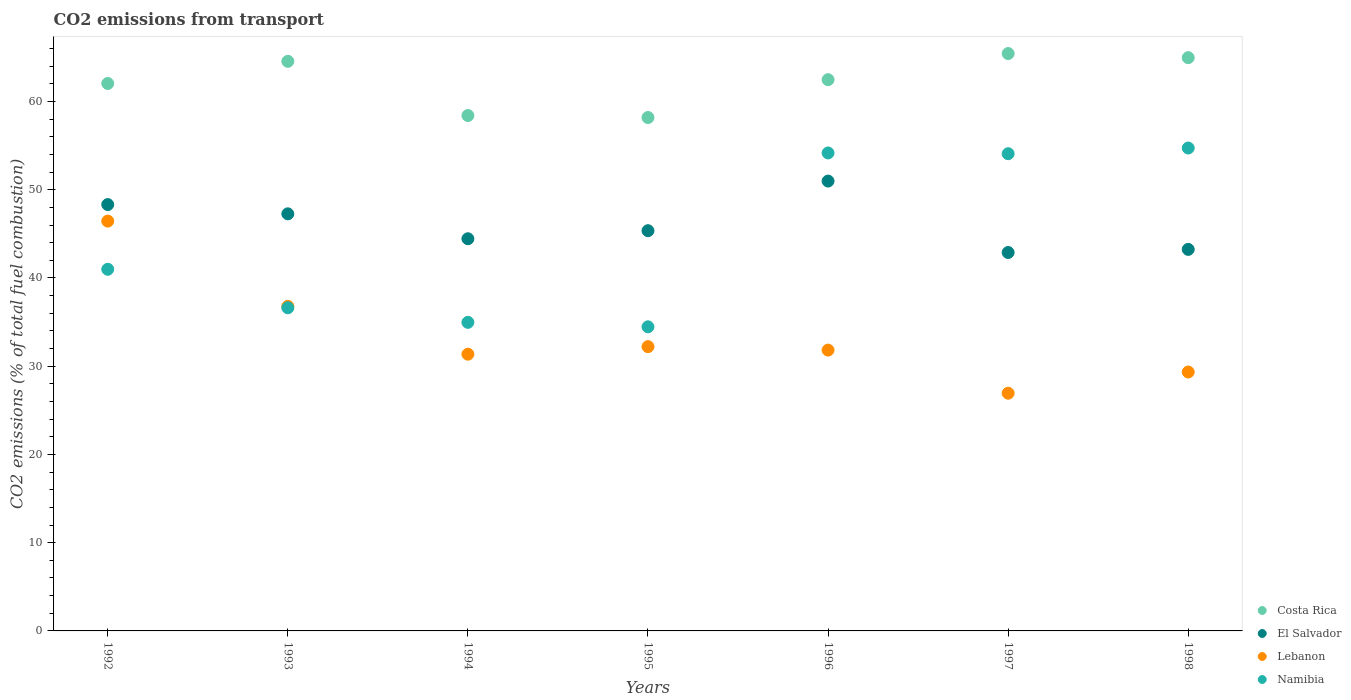Is the number of dotlines equal to the number of legend labels?
Provide a succinct answer. Yes. What is the total CO2 emitted in Costa Rica in 1992?
Provide a succinct answer. 62.04. Across all years, what is the maximum total CO2 emitted in Namibia?
Your answer should be very brief. 54.73. Across all years, what is the minimum total CO2 emitted in Namibia?
Provide a succinct answer. 34.46. In which year was the total CO2 emitted in Lebanon minimum?
Keep it short and to the point. 1997. What is the total total CO2 emitted in El Salvador in the graph?
Your response must be concise. 322.49. What is the difference between the total CO2 emitted in El Salvador in 1996 and that in 1998?
Provide a succinct answer. 7.74. What is the difference between the total CO2 emitted in Costa Rica in 1994 and the total CO2 emitted in Lebanon in 1997?
Offer a very short reply. 31.47. What is the average total CO2 emitted in El Salvador per year?
Your response must be concise. 46.07. In the year 1996, what is the difference between the total CO2 emitted in El Salvador and total CO2 emitted in Costa Rica?
Make the answer very short. -11.49. What is the ratio of the total CO2 emitted in El Salvador in 1994 to that in 1996?
Keep it short and to the point. 0.87. Is the total CO2 emitted in Lebanon in 1994 less than that in 1998?
Provide a short and direct response. No. What is the difference between the highest and the second highest total CO2 emitted in Costa Rica?
Your answer should be very brief. 0.47. What is the difference between the highest and the lowest total CO2 emitted in Namibia?
Give a very brief answer. 20.26. In how many years, is the total CO2 emitted in Namibia greater than the average total CO2 emitted in Namibia taken over all years?
Give a very brief answer. 3. Is the sum of the total CO2 emitted in Lebanon in 1995 and 1998 greater than the maximum total CO2 emitted in Namibia across all years?
Your response must be concise. Yes. Is the total CO2 emitted in Namibia strictly greater than the total CO2 emitted in Costa Rica over the years?
Your response must be concise. No. Is the total CO2 emitted in Namibia strictly less than the total CO2 emitted in Lebanon over the years?
Your answer should be very brief. No. What is the difference between two consecutive major ticks on the Y-axis?
Give a very brief answer. 10. Does the graph contain any zero values?
Your answer should be very brief. No. How many legend labels are there?
Ensure brevity in your answer.  4. What is the title of the graph?
Provide a short and direct response. CO2 emissions from transport. Does "Mauritius" appear as one of the legend labels in the graph?
Your answer should be very brief. No. What is the label or title of the X-axis?
Provide a succinct answer. Years. What is the label or title of the Y-axis?
Ensure brevity in your answer.  CO2 emissions (% of total fuel combustion). What is the CO2 emissions (% of total fuel combustion) in Costa Rica in 1992?
Provide a succinct answer. 62.04. What is the CO2 emissions (% of total fuel combustion) in El Salvador in 1992?
Offer a very short reply. 48.32. What is the CO2 emissions (% of total fuel combustion) in Lebanon in 1992?
Provide a succinct answer. 46.44. What is the CO2 emissions (% of total fuel combustion) of Namibia in 1992?
Give a very brief answer. 40.98. What is the CO2 emissions (% of total fuel combustion) of Costa Rica in 1993?
Keep it short and to the point. 64.55. What is the CO2 emissions (% of total fuel combustion) in El Salvador in 1993?
Your answer should be compact. 47.27. What is the CO2 emissions (% of total fuel combustion) in Lebanon in 1993?
Offer a terse response. 36.79. What is the CO2 emissions (% of total fuel combustion) in Namibia in 1993?
Offer a terse response. 36.62. What is the CO2 emissions (% of total fuel combustion) in Costa Rica in 1994?
Provide a short and direct response. 58.41. What is the CO2 emissions (% of total fuel combustion) of El Salvador in 1994?
Provide a short and direct response. 44.44. What is the CO2 emissions (% of total fuel combustion) in Lebanon in 1994?
Provide a succinct answer. 31.36. What is the CO2 emissions (% of total fuel combustion) of Namibia in 1994?
Ensure brevity in your answer.  34.97. What is the CO2 emissions (% of total fuel combustion) in Costa Rica in 1995?
Ensure brevity in your answer.  58.18. What is the CO2 emissions (% of total fuel combustion) of El Salvador in 1995?
Your answer should be compact. 45.36. What is the CO2 emissions (% of total fuel combustion) of Lebanon in 1995?
Your answer should be compact. 32.22. What is the CO2 emissions (% of total fuel combustion) of Namibia in 1995?
Give a very brief answer. 34.46. What is the CO2 emissions (% of total fuel combustion) of Costa Rica in 1996?
Provide a succinct answer. 62.47. What is the CO2 emissions (% of total fuel combustion) in El Salvador in 1996?
Offer a terse response. 50.98. What is the CO2 emissions (% of total fuel combustion) of Lebanon in 1996?
Ensure brevity in your answer.  31.82. What is the CO2 emissions (% of total fuel combustion) in Namibia in 1996?
Offer a terse response. 54.17. What is the CO2 emissions (% of total fuel combustion) of Costa Rica in 1997?
Provide a short and direct response. 65.43. What is the CO2 emissions (% of total fuel combustion) of El Salvador in 1997?
Offer a terse response. 42.89. What is the CO2 emissions (% of total fuel combustion) of Lebanon in 1997?
Offer a terse response. 26.94. What is the CO2 emissions (% of total fuel combustion) of Namibia in 1997?
Offer a very short reply. 54.08. What is the CO2 emissions (% of total fuel combustion) of Costa Rica in 1998?
Keep it short and to the point. 64.97. What is the CO2 emissions (% of total fuel combustion) of El Salvador in 1998?
Offer a very short reply. 43.24. What is the CO2 emissions (% of total fuel combustion) of Lebanon in 1998?
Your answer should be very brief. 29.34. What is the CO2 emissions (% of total fuel combustion) in Namibia in 1998?
Offer a terse response. 54.73. Across all years, what is the maximum CO2 emissions (% of total fuel combustion) in Costa Rica?
Offer a terse response. 65.43. Across all years, what is the maximum CO2 emissions (% of total fuel combustion) in El Salvador?
Your answer should be compact. 50.98. Across all years, what is the maximum CO2 emissions (% of total fuel combustion) in Lebanon?
Give a very brief answer. 46.44. Across all years, what is the maximum CO2 emissions (% of total fuel combustion) in Namibia?
Offer a terse response. 54.73. Across all years, what is the minimum CO2 emissions (% of total fuel combustion) of Costa Rica?
Provide a succinct answer. 58.18. Across all years, what is the minimum CO2 emissions (% of total fuel combustion) of El Salvador?
Your answer should be very brief. 42.89. Across all years, what is the minimum CO2 emissions (% of total fuel combustion) of Lebanon?
Offer a terse response. 26.94. Across all years, what is the minimum CO2 emissions (% of total fuel combustion) of Namibia?
Offer a terse response. 34.46. What is the total CO2 emissions (% of total fuel combustion) in Costa Rica in the graph?
Provide a succinct answer. 436.05. What is the total CO2 emissions (% of total fuel combustion) of El Salvador in the graph?
Your answer should be very brief. 322.49. What is the total CO2 emissions (% of total fuel combustion) of Lebanon in the graph?
Make the answer very short. 234.92. What is the total CO2 emissions (% of total fuel combustion) in Namibia in the graph?
Your response must be concise. 310.01. What is the difference between the CO2 emissions (% of total fuel combustion) in Costa Rica in 1992 and that in 1993?
Ensure brevity in your answer.  -2.51. What is the difference between the CO2 emissions (% of total fuel combustion) of El Salvador in 1992 and that in 1993?
Your answer should be very brief. 1.05. What is the difference between the CO2 emissions (% of total fuel combustion) in Lebanon in 1992 and that in 1993?
Offer a very short reply. 9.66. What is the difference between the CO2 emissions (% of total fuel combustion) of Namibia in 1992 and that in 1993?
Offer a very short reply. 4.36. What is the difference between the CO2 emissions (% of total fuel combustion) of Costa Rica in 1992 and that in 1994?
Your answer should be very brief. 3.63. What is the difference between the CO2 emissions (% of total fuel combustion) of El Salvador in 1992 and that in 1994?
Your answer should be compact. 3.87. What is the difference between the CO2 emissions (% of total fuel combustion) in Lebanon in 1992 and that in 1994?
Make the answer very short. 15.08. What is the difference between the CO2 emissions (% of total fuel combustion) of Namibia in 1992 and that in 1994?
Keep it short and to the point. 6.01. What is the difference between the CO2 emissions (% of total fuel combustion) in Costa Rica in 1992 and that in 1995?
Your response must be concise. 3.86. What is the difference between the CO2 emissions (% of total fuel combustion) of El Salvador in 1992 and that in 1995?
Provide a short and direct response. 2.96. What is the difference between the CO2 emissions (% of total fuel combustion) of Lebanon in 1992 and that in 1995?
Your answer should be very brief. 14.23. What is the difference between the CO2 emissions (% of total fuel combustion) of Namibia in 1992 and that in 1995?
Provide a short and direct response. 6.52. What is the difference between the CO2 emissions (% of total fuel combustion) in Costa Rica in 1992 and that in 1996?
Provide a succinct answer. -0.43. What is the difference between the CO2 emissions (% of total fuel combustion) in El Salvador in 1992 and that in 1996?
Make the answer very short. -2.66. What is the difference between the CO2 emissions (% of total fuel combustion) in Lebanon in 1992 and that in 1996?
Offer a very short reply. 14.62. What is the difference between the CO2 emissions (% of total fuel combustion) in Namibia in 1992 and that in 1996?
Give a very brief answer. -13.18. What is the difference between the CO2 emissions (% of total fuel combustion) in Costa Rica in 1992 and that in 1997?
Keep it short and to the point. -3.39. What is the difference between the CO2 emissions (% of total fuel combustion) in El Salvador in 1992 and that in 1997?
Your answer should be very brief. 5.43. What is the difference between the CO2 emissions (% of total fuel combustion) in Lebanon in 1992 and that in 1997?
Give a very brief answer. 19.5. What is the difference between the CO2 emissions (% of total fuel combustion) in Namibia in 1992 and that in 1997?
Your response must be concise. -13.1. What is the difference between the CO2 emissions (% of total fuel combustion) of Costa Rica in 1992 and that in 1998?
Offer a terse response. -2.92. What is the difference between the CO2 emissions (% of total fuel combustion) in El Salvador in 1992 and that in 1998?
Provide a short and direct response. 5.08. What is the difference between the CO2 emissions (% of total fuel combustion) in Lebanon in 1992 and that in 1998?
Make the answer very short. 17.1. What is the difference between the CO2 emissions (% of total fuel combustion) of Namibia in 1992 and that in 1998?
Give a very brief answer. -13.74. What is the difference between the CO2 emissions (% of total fuel combustion) of Costa Rica in 1993 and that in 1994?
Your answer should be compact. 6.14. What is the difference between the CO2 emissions (% of total fuel combustion) in El Salvador in 1993 and that in 1994?
Ensure brevity in your answer.  2.82. What is the difference between the CO2 emissions (% of total fuel combustion) in Lebanon in 1993 and that in 1994?
Your response must be concise. 5.42. What is the difference between the CO2 emissions (% of total fuel combustion) of Namibia in 1993 and that in 1994?
Provide a succinct answer. 1.65. What is the difference between the CO2 emissions (% of total fuel combustion) in Costa Rica in 1993 and that in 1995?
Ensure brevity in your answer.  6.37. What is the difference between the CO2 emissions (% of total fuel combustion) in El Salvador in 1993 and that in 1995?
Your answer should be compact. 1.91. What is the difference between the CO2 emissions (% of total fuel combustion) in Lebanon in 1993 and that in 1995?
Ensure brevity in your answer.  4.57. What is the difference between the CO2 emissions (% of total fuel combustion) in Namibia in 1993 and that in 1995?
Offer a terse response. 2.16. What is the difference between the CO2 emissions (% of total fuel combustion) in Costa Rica in 1993 and that in 1996?
Keep it short and to the point. 2.08. What is the difference between the CO2 emissions (% of total fuel combustion) in El Salvador in 1993 and that in 1996?
Offer a terse response. -3.71. What is the difference between the CO2 emissions (% of total fuel combustion) of Lebanon in 1993 and that in 1996?
Offer a terse response. 4.96. What is the difference between the CO2 emissions (% of total fuel combustion) in Namibia in 1993 and that in 1996?
Your response must be concise. -17.55. What is the difference between the CO2 emissions (% of total fuel combustion) of Costa Rica in 1993 and that in 1997?
Provide a succinct answer. -0.88. What is the difference between the CO2 emissions (% of total fuel combustion) of El Salvador in 1993 and that in 1997?
Your answer should be very brief. 4.38. What is the difference between the CO2 emissions (% of total fuel combustion) in Lebanon in 1993 and that in 1997?
Provide a short and direct response. 9.84. What is the difference between the CO2 emissions (% of total fuel combustion) in Namibia in 1993 and that in 1997?
Give a very brief answer. -17.46. What is the difference between the CO2 emissions (% of total fuel combustion) in Costa Rica in 1993 and that in 1998?
Provide a succinct answer. -0.42. What is the difference between the CO2 emissions (% of total fuel combustion) in El Salvador in 1993 and that in 1998?
Your response must be concise. 4.03. What is the difference between the CO2 emissions (% of total fuel combustion) in Lebanon in 1993 and that in 1998?
Your answer should be compact. 7.44. What is the difference between the CO2 emissions (% of total fuel combustion) of Namibia in 1993 and that in 1998?
Your answer should be compact. -18.11. What is the difference between the CO2 emissions (% of total fuel combustion) of Costa Rica in 1994 and that in 1995?
Provide a short and direct response. 0.23. What is the difference between the CO2 emissions (% of total fuel combustion) of El Salvador in 1994 and that in 1995?
Offer a terse response. -0.91. What is the difference between the CO2 emissions (% of total fuel combustion) of Lebanon in 1994 and that in 1995?
Keep it short and to the point. -0.86. What is the difference between the CO2 emissions (% of total fuel combustion) of Namibia in 1994 and that in 1995?
Offer a very short reply. 0.51. What is the difference between the CO2 emissions (% of total fuel combustion) of Costa Rica in 1994 and that in 1996?
Your answer should be compact. -4.06. What is the difference between the CO2 emissions (% of total fuel combustion) in El Salvador in 1994 and that in 1996?
Your answer should be very brief. -6.54. What is the difference between the CO2 emissions (% of total fuel combustion) in Lebanon in 1994 and that in 1996?
Your answer should be compact. -0.46. What is the difference between the CO2 emissions (% of total fuel combustion) in Namibia in 1994 and that in 1996?
Provide a succinct answer. -19.2. What is the difference between the CO2 emissions (% of total fuel combustion) of Costa Rica in 1994 and that in 1997?
Offer a terse response. -7.02. What is the difference between the CO2 emissions (% of total fuel combustion) in El Salvador in 1994 and that in 1997?
Make the answer very short. 1.56. What is the difference between the CO2 emissions (% of total fuel combustion) of Lebanon in 1994 and that in 1997?
Keep it short and to the point. 4.42. What is the difference between the CO2 emissions (% of total fuel combustion) in Namibia in 1994 and that in 1997?
Offer a terse response. -19.11. What is the difference between the CO2 emissions (% of total fuel combustion) of Costa Rica in 1994 and that in 1998?
Ensure brevity in your answer.  -6.56. What is the difference between the CO2 emissions (% of total fuel combustion) of El Salvador in 1994 and that in 1998?
Make the answer very short. 1.21. What is the difference between the CO2 emissions (% of total fuel combustion) in Lebanon in 1994 and that in 1998?
Offer a very short reply. 2.02. What is the difference between the CO2 emissions (% of total fuel combustion) of Namibia in 1994 and that in 1998?
Provide a succinct answer. -19.76. What is the difference between the CO2 emissions (% of total fuel combustion) of Costa Rica in 1995 and that in 1996?
Make the answer very short. -4.29. What is the difference between the CO2 emissions (% of total fuel combustion) of El Salvador in 1995 and that in 1996?
Your answer should be very brief. -5.62. What is the difference between the CO2 emissions (% of total fuel combustion) in Lebanon in 1995 and that in 1996?
Give a very brief answer. 0.39. What is the difference between the CO2 emissions (% of total fuel combustion) in Namibia in 1995 and that in 1996?
Make the answer very short. -19.7. What is the difference between the CO2 emissions (% of total fuel combustion) in Costa Rica in 1995 and that in 1997?
Your response must be concise. -7.25. What is the difference between the CO2 emissions (% of total fuel combustion) in El Salvador in 1995 and that in 1997?
Ensure brevity in your answer.  2.47. What is the difference between the CO2 emissions (% of total fuel combustion) of Lebanon in 1995 and that in 1997?
Your answer should be very brief. 5.28. What is the difference between the CO2 emissions (% of total fuel combustion) of Namibia in 1995 and that in 1997?
Provide a short and direct response. -19.62. What is the difference between the CO2 emissions (% of total fuel combustion) in Costa Rica in 1995 and that in 1998?
Your answer should be very brief. -6.78. What is the difference between the CO2 emissions (% of total fuel combustion) in El Salvador in 1995 and that in 1998?
Ensure brevity in your answer.  2.12. What is the difference between the CO2 emissions (% of total fuel combustion) in Lebanon in 1995 and that in 1998?
Provide a short and direct response. 2.88. What is the difference between the CO2 emissions (% of total fuel combustion) in Namibia in 1995 and that in 1998?
Make the answer very short. -20.26. What is the difference between the CO2 emissions (% of total fuel combustion) in Costa Rica in 1996 and that in 1997?
Your answer should be compact. -2.96. What is the difference between the CO2 emissions (% of total fuel combustion) of El Salvador in 1996 and that in 1997?
Offer a terse response. 8.09. What is the difference between the CO2 emissions (% of total fuel combustion) in Lebanon in 1996 and that in 1997?
Provide a succinct answer. 4.88. What is the difference between the CO2 emissions (% of total fuel combustion) in Namibia in 1996 and that in 1997?
Provide a short and direct response. 0.09. What is the difference between the CO2 emissions (% of total fuel combustion) of Costa Rica in 1996 and that in 1998?
Your answer should be compact. -2.5. What is the difference between the CO2 emissions (% of total fuel combustion) in El Salvador in 1996 and that in 1998?
Give a very brief answer. 7.74. What is the difference between the CO2 emissions (% of total fuel combustion) in Lebanon in 1996 and that in 1998?
Offer a terse response. 2.48. What is the difference between the CO2 emissions (% of total fuel combustion) in Namibia in 1996 and that in 1998?
Provide a short and direct response. -0.56. What is the difference between the CO2 emissions (% of total fuel combustion) of Costa Rica in 1997 and that in 1998?
Make the answer very short. 0.47. What is the difference between the CO2 emissions (% of total fuel combustion) in El Salvador in 1997 and that in 1998?
Offer a terse response. -0.35. What is the difference between the CO2 emissions (% of total fuel combustion) of Lebanon in 1997 and that in 1998?
Provide a short and direct response. -2.4. What is the difference between the CO2 emissions (% of total fuel combustion) of Namibia in 1997 and that in 1998?
Offer a very short reply. -0.64. What is the difference between the CO2 emissions (% of total fuel combustion) in Costa Rica in 1992 and the CO2 emissions (% of total fuel combustion) in El Salvador in 1993?
Give a very brief answer. 14.77. What is the difference between the CO2 emissions (% of total fuel combustion) of Costa Rica in 1992 and the CO2 emissions (% of total fuel combustion) of Lebanon in 1993?
Keep it short and to the point. 25.26. What is the difference between the CO2 emissions (% of total fuel combustion) in Costa Rica in 1992 and the CO2 emissions (% of total fuel combustion) in Namibia in 1993?
Ensure brevity in your answer.  25.42. What is the difference between the CO2 emissions (% of total fuel combustion) of El Salvador in 1992 and the CO2 emissions (% of total fuel combustion) of Lebanon in 1993?
Your answer should be very brief. 11.53. What is the difference between the CO2 emissions (% of total fuel combustion) of El Salvador in 1992 and the CO2 emissions (% of total fuel combustion) of Namibia in 1993?
Keep it short and to the point. 11.7. What is the difference between the CO2 emissions (% of total fuel combustion) in Lebanon in 1992 and the CO2 emissions (% of total fuel combustion) in Namibia in 1993?
Your response must be concise. 9.82. What is the difference between the CO2 emissions (% of total fuel combustion) in Costa Rica in 1992 and the CO2 emissions (% of total fuel combustion) in El Salvador in 1994?
Ensure brevity in your answer.  17.6. What is the difference between the CO2 emissions (% of total fuel combustion) of Costa Rica in 1992 and the CO2 emissions (% of total fuel combustion) of Lebanon in 1994?
Ensure brevity in your answer.  30.68. What is the difference between the CO2 emissions (% of total fuel combustion) in Costa Rica in 1992 and the CO2 emissions (% of total fuel combustion) in Namibia in 1994?
Your answer should be very brief. 27.07. What is the difference between the CO2 emissions (% of total fuel combustion) in El Salvador in 1992 and the CO2 emissions (% of total fuel combustion) in Lebanon in 1994?
Your response must be concise. 16.96. What is the difference between the CO2 emissions (% of total fuel combustion) of El Salvador in 1992 and the CO2 emissions (% of total fuel combustion) of Namibia in 1994?
Provide a succinct answer. 13.35. What is the difference between the CO2 emissions (% of total fuel combustion) in Lebanon in 1992 and the CO2 emissions (% of total fuel combustion) in Namibia in 1994?
Keep it short and to the point. 11.47. What is the difference between the CO2 emissions (% of total fuel combustion) of Costa Rica in 1992 and the CO2 emissions (% of total fuel combustion) of El Salvador in 1995?
Give a very brief answer. 16.69. What is the difference between the CO2 emissions (% of total fuel combustion) of Costa Rica in 1992 and the CO2 emissions (% of total fuel combustion) of Lebanon in 1995?
Your answer should be compact. 29.82. What is the difference between the CO2 emissions (% of total fuel combustion) of Costa Rica in 1992 and the CO2 emissions (% of total fuel combustion) of Namibia in 1995?
Ensure brevity in your answer.  27.58. What is the difference between the CO2 emissions (% of total fuel combustion) of El Salvador in 1992 and the CO2 emissions (% of total fuel combustion) of Lebanon in 1995?
Provide a succinct answer. 16.1. What is the difference between the CO2 emissions (% of total fuel combustion) in El Salvador in 1992 and the CO2 emissions (% of total fuel combustion) in Namibia in 1995?
Provide a succinct answer. 13.85. What is the difference between the CO2 emissions (% of total fuel combustion) of Lebanon in 1992 and the CO2 emissions (% of total fuel combustion) of Namibia in 1995?
Make the answer very short. 11.98. What is the difference between the CO2 emissions (% of total fuel combustion) in Costa Rica in 1992 and the CO2 emissions (% of total fuel combustion) in El Salvador in 1996?
Keep it short and to the point. 11.06. What is the difference between the CO2 emissions (% of total fuel combustion) in Costa Rica in 1992 and the CO2 emissions (% of total fuel combustion) in Lebanon in 1996?
Give a very brief answer. 30.22. What is the difference between the CO2 emissions (% of total fuel combustion) in Costa Rica in 1992 and the CO2 emissions (% of total fuel combustion) in Namibia in 1996?
Offer a very short reply. 7.88. What is the difference between the CO2 emissions (% of total fuel combustion) of El Salvador in 1992 and the CO2 emissions (% of total fuel combustion) of Lebanon in 1996?
Ensure brevity in your answer.  16.49. What is the difference between the CO2 emissions (% of total fuel combustion) of El Salvador in 1992 and the CO2 emissions (% of total fuel combustion) of Namibia in 1996?
Offer a terse response. -5.85. What is the difference between the CO2 emissions (% of total fuel combustion) in Lebanon in 1992 and the CO2 emissions (% of total fuel combustion) in Namibia in 1996?
Your response must be concise. -7.72. What is the difference between the CO2 emissions (% of total fuel combustion) in Costa Rica in 1992 and the CO2 emissions (% of total fuel combustion) in El Salvador in 1997?
Ensure brevity in your answer.  19.16. What is the difference between the CO2 emissions (% of total fuel combustion) of Costa Rica in 1992 and the CO2 emissions (% of total fuel combustion) of Lebanon in 1997?
Your answer should be compact. 35.1. What is the difference between the CO2 emissions (% of total fuel combustion) of Costa Rica in 1992 and the CO2 emissions (% of total fuel combustion) of Namibia in 1997?
Make the answer very short. 7.96. What is the difference between the CO2 emissions (% of total fuel combustion) in El Salvador in 1992 and the CO2 emissions (% of total fuel combustion) in Lebanon in 1997?
Provide a succinct answer. 21.38. What is the difference between the CO2 emissions (% of total fuel combustion) in El Salvador in 1992 and the CO2 emissions (% of total fuel combustion) in Namibia in 1997?
Offer a very short reply. -5.76. What is the difference between the CO2 emissions (% of total fuel combustion) in Lebanon in 1992 and the CO2 emissions (% of total fuel combustion) in Namibia in 1997?
Your answer should be very brief. -7.64. What is the difference between the CO2 emissions (% of total fuel combustion) in Costa Rica in 1992 and the CO2 emissions (% of total fuel combustion) in El Salvador in 1998?
Ensure brevity in your answer.  18.8. What is the difference between the CO2 emissions (% of total fuel combustion) of Costa Rica in 1992 and the CO2 emissions (% of total fuel combustion) of Lebanon in 1998?
Offer a very short reply. 32.7. What is the difference between the CO2 emissions (% of total fuel combustion) in Costa Rica in 1992 and the CO2 emissions (% of total fuel combustion) in Namibia in 1998?
Keep it short and to the point. 7.32. What is the difference between the CO2 emissions (% of total fuel combustion) of El Salvador in 1992 and the CO2 emissions (% of total fuel combustion) of Lebanon in 1998?
Ensure brevity in your answer.  18.98. What is the difference between the CO2 emissions (% of total fuel combustion) in El Salvador in 1992 and the CO2 emissions (% of total fuel combustion) in Namibia in 1998?
Provide a succinct answer. -6.41. What is the difference between the CO2 emissions (% of total fuel combustion) of Lebanon in 1992 and the CO2 emissions (% of total fuel combustion) of Namibia in 1998?
Provide a succinct answer. -8.28. What is the difference between the CO2 emissions (% of total fuel combustion) in Costa Rica in 1993 and the CO2 emissions (% of total fuel combustion) in El Salvador in 1994?
Your answer should be compact. 20.11. What is the difference between the CO2 emissions (% of total fuel combustion) of Costa Rica in 1993 and the CO2 emissions (% of total fuel combustion) of Lebanon in 1994?
Your answer should be very brief. 33.19. What is the difference between the CO2 emissions (% of total fuel combustion) of Costa Rica in 1993 and the CO2 emissions (% of total fuel combustion) of Namibia in 1994?
Make the answer very short. 29.58. What is the difference between the CO2 emissions (% of total fuel combustion) in El Salvador in 1993 and the CO2 emissions (% of total fuel combustion) in Lebanon in 1994?
Your response must be concise. 15.91. What is the difference between the CO2 emissions (% of total fuel combustion) of El Salvador in 1993 and the CO2 emissions (% of total fuel combustion) of Namibia in 1994?
Ensure brevity in your answer.  12.3. What is the difference between the CO2 emissions (% of total fuel combustion) of Lebanon in 1993 and the CO2 emissions (% of total fuel combustion) of Namibia in 1994?
Your answer should be very brief. 1.82. What is the difference between the CO2 emissions (% of total fuel combustion) of Costa Rica in 1993 and the CO2 emissions (% of total fuel combustion) of El Salvador in 1995?
Give a very brief answer. 19.19. What is the difference between the CO2 emissions (% of total fuel combustion) in Costa Rica in 1993 and the CO2 emissions (% of total fuel combustion) in Lebanon in 1995?
Offer a very short reply. 32.33. What is the difference between the CO2 emissions (% of total fuel combustion) in Costa Rica in 1993 and the CO2 emissions (% of total fuel combustion) in Namibia in 1995?
Make the answer very short. 30.09. What is the difference between the CO2 emissions (% of total fuel combustion) of El Salvador in 1993 and the CO2 emissions (% of total fuel combustion) of Lebanon in 1995?
Provide a succinct answer. 15.05. What is the difference between the CO2 emissions (% of total fuel combustion) of El Salvador in 1993 and the CO2 emissions (% of total fuel combustion) of Namibia in 1995?
Your response must be concise. 12.8. What is the difference between the CO2 emissions (% of total fuel combustion) in Lebanon in 1993 and the CO2 emissions (% of total fuel combustion) in Namibia in 1995?
Offer a terse response. 2.32. What is the difference between the CO2 emissions (% of total fuel combustion) of Costa Rica in 1993 and the CO2 emissions (% of total fuel combustion) of El Salvador in 1996?
Provide a short and direct response. 13.57. What is the difference between the CO2 emissions (% of total fuel combustion) of Costa Rica in 1993 and the CO2 emissions (% of total fuel combustion) of Lebanon in 1996?
Make the answer very short. 32.73. What is the difference between the CO2 emissions (% of total fuel combustion) of Costa Rica in 1993 and the CO2 emissions (% of total fuel combustion) of Namibia in 1996?
Your response must be concise. 10.38. What is the difference between the CO2 emissions (% of total fuel combustion) of El Salvador in 1993 and the CO2 emissions (% of total fuel combustion) of Lebanon in 1996?
Ensure brevity in your answer.  15.44. What is the difference between the CO2 emissions (% of total fuel combustion) of El Salvador in 1993 and the CO2 emissions (% of total fuel combustion) of Namibia in 1996?
Your response must be concise. -6.9. What is the difference between the CO2 emissions (% of total fuel combustion) of Lebanon in 1993 and the CO2 emissions (% of total fuel combustion) of Namibia in 1996?
Give a very brief answer. -17.38. What is the difference between the CO2 emissions (% of total fuel combustion) of Costa Rica in 1993 and the CO2 emissions (% of total fuel combustion) of El Salvador in 1997?
Your answer should be compact. 21.66. What is the difference between the CO2 emissions (% of total fuel combustion) in Costa Rica in 1993 and the CO2 emissions (% of total fuel combustion) in Lebanon in 1997?
Your answer should be compact. 37.61. What is the difference between the CO2 emissions (% of total fuel combustion) in Costa Rica in 1993 and the CO2 emissions (% of total fuel combustion) in Namibia in 1997?
Offer a terse response. 10.47. What is the difference between the CO2 emissions (% of total fuel combustion) of El Salvador in 1993 and the CO2 emissions (% of total fuel combustion) of Lebanon in 1997?
Your answer should be compact. 20.33. What is the difference between the CO2 emissions (% of total fuel combustion) of El Salvador in 1993 and the CO2 emissions (% of total fuel combustion) of Namibia in 1997?
Offer a very short reply. -6.81. What is the difference between the CO2 emissions (% of total fuel combustion) of Lebanon in 1993 and the CO2 emissions (% of total fuel combustion) of Namibia in 1997?
Provide a short and direct response. -17.3. What is the difference between the CO2 emissions (% of total fuel combustion) of Costa Rica in 1993 and the CO2 emissions (% of total fuel combustion) of El Salvador in 1998?
Provide a succinct answer. 21.31. What is the difference between the CO2 emissions (% of total fuel combustion) in Costa Rica in 1993 and the CO2 emissions (% of total fuel combustion) in Lebanon in 1998?
Provide a short and direct response. 35.21. What is the difference between the CO2 emissions (% of total fuel combustion) in Costa Rica in 1993 and the CO2 emissions (% of total fuel combustion) in Namibia in 1998?
Make the answer very short. 9.82. What is the difference between the CO2 emissions (% of total fuel combustion) in El Salvador in 1993 and the CO2 emissions (% of total fuel combustion) in Lebanon in 1998?
Keep it short and to the point. 17.93. What is the difference between the CO2 emissions (% of total fuel combustion) in El Salvador in 1993 and the CO2 emissions (% of total fuel combustion) in Namibia in 1998?
Offer a terse response. -7.46. What is the difference between the CO2 emissions (% of total fuel combustion) in Lebanon in 1993 and the CO2 emissions (% of total fuel combustion) in Namibia in 1998?
Provide a short and direct response. -17.94. What is the difference between the CO2 emissions (% of total fuel combustion) in Costa Rica in 1994 and the CO2 emissions (% of total fuel combustion) in El Salvador in 1995?
Ensure brevity in your answer.  13.05. What is the difference between the CO2 emissions (% of total fuel combustion) in Costa Rica in 1994 and the CO2 emissions (% of total fuel combustion) in Lebanon in 1995?
Provide a short and direct response. 26.19. What is the difference between the CO2 emissions (% of total fuel combustion) of Costa Rica in 1994 and the CO2 emissions (% of total fuel combustion) of Namibia in 1995?
Your answer should be very brief. 23.95. What is the difference between the CO2 emissions (% of total fuel combustion) in El Salvador in 1994 and the CO2 emissions (% of total fuel combustion) in Lebanon in 1995?
Keep it short and to the point. 12.23. What is the difference between the CO2 emissions (% of total fuel combustion) of El Salvador in 1994 and the CO2 emissions (% of total fuel combustion) of Namibia in 1995?
Provide a short and direct response. 9.98. What is the difference between the CO2 emissions (% of total fuel combustion) in Lebanon in 1994 and the CO2 emissions (% of total fuel combustion) in Namibia in 1995?
Your response must be concise. -3.1. What is the difference between the CO2 emissions (% of total fuel combustion) in Costa Rica in 1994 and the CO2 emissions (% of total fuel combustion) in El Salvador in 1996?
Your answer should be very brief. 7.43. What is the difference between the CO2 emissions (% of total fuel combustion) in Costa Rica in 1994 and the CO2 emissions (% of total fuel combustion) in Lebanon in 1996?
Provide a short and direct response. 26.58. What is the difference between the CO2 emissions (% of total fuel combustion) of Costa Rica in 1994 and the CO2 emissions (% of total fuel combustion) of Namibia in 1996?
Offer a very short reply. 4.24. What is the difference between the CO2 emissions (% of total fuel combustion) of El Salvador in 1994 and the CO2 emissions (% of total fuel combustion) of Lebanon in 1996?
Provide a short and direct response. 12.62. What is the difference between the CO2 emissions (% of total fuel combustion) in El Salvador in 1994 and the CO2 emissions (% of total fuel combustion) in Namibia in 1996?
Keep it short and to the point. -9.72. What is the difference between the CO2 emissions (% of total fuel combustion) in Lebanon in 1994 and the CO2 emissions (% of total fuel combustion) in Namibia in 1996?
Provide a short and direct response. -22.8. What is the difference between the CO2 emissions (% of total fuel combustion) of Costa Rica in 1994 and the CO2 emissions (% of total fuel combustion) of El Salvador in 1997?
Provide a short and direct response. 15.52. What is the difference between the CO2 emissions (% of total fuel combustion) in Costa Rica in 1994 and the CO2 emissions (% of total fuel combustion) in Lebanon in 1997?
Make the answer very short. 31.47. What is the difference between the CO2 emissions (% of total fuel combustion) in Costa Rica in 1994 and the CO2 emissions (% of total fuel combustion) in Namibia in 1997?
Your answer should be very brief. 4.33. What is the difference between the CO2 emissions (% of total fuel combustion) in El Salvador in 1994 and the CO2 emissions (% of total fuel combustion) in Lebanon in 1997?
Offer a very short reply. 17.5. What is the difference between the CO2 emissions (% of total fuel combustion) in El Salvador in 1994 and the CO2 emissions (% of total fuel combustion) in Namibia in 1997?
Offer a terse response. -9.64. What is the difference between the CO2 emissions (% of total fuel combustion) of Lebanon in 1994 and the CO2 emissions (% of total fuel combustion) of Namibia in 1997?
Make the answer very short. -22.72. What is the difference between the CO2 emissions (% of total fuel combustion) of Costa Rica in 1994 and the CO2 emissions (% of total fuel combustion) of El Salvador in 1998?
Provide a short and direct response. 15.17. What is the difference between the CO2 emissions (% of total fuel combustion) of Costa Rica in 1994 and the CO2 emissions (% of total fuel combustion) of Lebanon in 1998?
Provide a short and direct response. 29.07. What is the difference between the CO2 emissions (% of total fuel combustion) of Costa Rica in 1994 and the CO2 emissions (% of total fuel combustion) of Namibia in 1998?
Your response must be concise. 3.68. What is the difference between the CO2 emissions (% of total fuel combustion) in El Salvador in 1994 and the CO2 emissions (% of total fuel combustion) in Lebanon in 1998?
Give a very brief answer. 15.1. What is the difference between the CO2 emissions (% of total fuel combustion) of El Salvador in 1994 and the CO2 emissions (% of total fuel combustion) of Namibia in 1998?
Your response must be concise. -10.28. What is the difference between the CO2 emissions (% of total fuel combustion) in Lebanon in 1994 and the CO2 emissions (% of total fuel combustion) in Namibia in 1998?
Your answer should be very brief. -23.36. What is the difference between the CO2 emissions (% of total fuel combustion) of Costa Rica in 1995 and the CO2 emissions (% of total fuel combustion) of El Salvador in 1996?
Offer a terse response. 7.2. What is the difference between the CO2 emissions (% of total fuel combustion) in Costa Rica in 1995 and the CO2 emissions (% of total fuel combustion) in Lebanon in 1996?
Your response must be concise. 26.36. What is the difference between the CO2 emissions (% of total fuel combustion) in Costa Rica in 1995 and the CO2 emissions (% of total fuel combustion) in Namibia in 1996?
Your response must be concise. 4.02. What is the difference between the CO2 emissions (% of total fuel combustion) of El Salvador in 1995 and the CO2 emissions (% of total fuel combustion) of Lebanon in 1996?
Make the answer very short. 13.53. What is the difference between the CO2 emissions (% of total fuel combustion) of El Salvador in 1995 and the CO2 emissions (% of total fuel combustion) of Namibia in 1996?
Your answer should be very brief. -8.81. What is the difference between the CO2 emissions (% of total fuel combustion) in Lebanon in 1995 and the CO2 emissions (% of total fuel combustion) in Namibia in 1996?
Offer a very short reply. -21.95. What is the difference between the CO2 emissions (% of total fuel combustion) of Costa Rica in 1995 and the CO2 emissions (% of total fuel combustion) of El Salvador in 1997?
Your answer should be compact. 15.3. What is the difference between the CO2 emissions (% of total fuel combustion) of Costa Rica in 1995 and the CO2 emissions (% of total fuel combustion) of Lebanon in 1997?
Your answer should be compact. 31.24. What is the difference between the CO2 emissions (% of total fuel combustion) of Costa Rica in 1995 and the CO2 emissions (% of total fuel combustion) of Namibia in 1997?
Your answer should be compact. 4.1. What is the difference between the CO2 emissions (% of total fuel combustion) in El Salvador in 1995 and the CO2 emissions (% of total fuel combustion) in Lebanon in 1997?
Provide a short and direct response. 18.42. What is the difference between the CO2 emissions (% of total fuel combustion) of El Salvador in 1995 and the CO2 emissions (% of total fuel combustion) of Namibia in 1997?
Offer a terse response. -8.73. What is the difference between the CO2 emissions (% of total fuel combustion) in Lebanon in 1995 and the CO2 emissions (% of total fuel combustion) in Namibia in 1997?
Your response must be concise. -21.86. What is the difference between the CO2 emissions (% of total fuel combustion) of Costa Rica in 1995 and the CO2 emissions (% of total fuel combustion) of El Salvador in 1998?
Keep it short and to the point. 14.94. What is the difference between the CO2 emissions (% of total fuel combustion) of Costa Rica in 1995 and the CO2 emissions (% of total fuel combustion) of Lebanon in 1998?
Provide a succinct answer. 28.84. What is the difference between the CO2 emissions (% of total fuel combustion) in Costa Rica in 1995 and the CO2 emissions (% of total fuel combustion) in Namibia in 1998?
Your answer should be compact. 3.46. What is the difference between the CO2 emissions (% of total fuel combustion) of El Salvador in 1995 and the CO2 emissions (% of total fuel combustion) of Lebanon in 1998?
Your response must be concise. 16.02. What is the difference between the CO2 emissions (% of total fuel combustion) in El Salvador in 1995 and the CO2 emissions (% of total fuel combustion) in Namibia in 1998?
Provide a succinct answer. -9.37. What is the difference between the CO2 emissions (% of total fuel combustion) of Lebanon in 1995 and the CO2 emissions (% of total fuel combustion) of Namibia in 1998?
Your answer should be very brief. -22.51. What is the difference between the CO2 emissions (% of total fuel combustion) of Costa Rica in 1996 and the CO2 emissions (% of total fuel combustion) of El Salvador in 1997?
Provide a succinct answer. 19.58. What is the difference between the CO2 emissions (% of total fuel combustion) of Costa Rica in 1996 and the CO2 emissions (% of total fuel combustion) of Lebanon in 1997?
Keep it short and to the point. 35.53. What is the difference between the CO2 emissions (% of total fuel combustion) in Costa Rica in 1996 and the CO2 emissions (% of total fuel combustion) in Namibia in 1997?
Your answer should be compact. 8.39. What is the difference between the CO2 emissions (% of total fuel combustion) in El Salvador in 1996 and the CO2 emissions (% of total fuel combustion) in Lebanon in 1997?
Offer a terse response. 24.04. What is the difference between the CO2 emissions (% of total fuel combustion) in El Salvador in 1996 and the CO2 emissions (% of total fuel combustion) in Namibia in 1997?
Your answer should be very brief. -3.1. What is the difference between the CO2 emissions (% of total fuel combustion) of Lebanon in 1996 and the CO2 emissions (% of total fuel combustion) of Namibia in 1997?
Your answer should be very brief. -22.26. What is the difference between the CO2 emissions (% of total fuel combustion) in Costa Rica in 1996 and the CO2 emissions (% of total fuel combustion) in El Salvador in 1998?
Your answer should be compact. 19.23. What is the difference between the CO2 emissions (% of total fuel combustion) of Costa Rica in 1996 and the CO2 emissions (% of total fuel combustion) of Lebanon in 1998?
Your answer should be compact. 33.13. What is the difference between the CO2 emissions (% of total fuel combustion) of Costa Rica in 1996 and the CO2 emissions (% of total fuel combustion) of Namibia in 1998?
Keep it short and to the point. 7.74. What is the difference between the CO2 emissions (% of total fuel combustion) in El Salvador in 1996 and the CO2 emissions (% of total fuel combustion) in Lebanon in 1998?
Provide a short and direct response. 21.64. What is the difference between the CO2 emissions (% of total fuel combustion) of El Salvador in 1996 and the CO2 emissions (% of total fuel combustion) of Namibia in 1998?
Provide a succinct answer. -3.75. What is the difference between the CO2 emissions (% of total fuel combustion) in Lebanon in 1996 and the CO2 emissions (% of total fuel combustion) in Namibia in 1998?
Offer a terse response. -22.9. What is the difference between the CO2 emissions (% of total fuel combustion) in Costa Rica in 1997 and the CO2 emissions (% of total fuel combustion) in El Salvador in 1998?
Keep it short and to the point. 22.19. What is the difference between the CO2 emissions (% of total fuel combustion) in Costa Rica in 1997 and the CO2 emissions (% of total fuel combustion) in Lebanon in 1998?
Your answer should be very brief. 36.09. What is the difference between the CO2 emissions (% of total fuel combustion) of Costa Rica in 1997 and the CO2 emissions (% of total fuel combustion) of Namibia in 1998?
Provide a succinct answer. 10.71. What is the difference between the CO2 emissions (% of total fuel combustion) of El Salvador in 1997 and the CO2 emissions (% of total fuel combustion) of Lebanon in 1998?
Your response must be concise. 13.54. What is the difference between the CO2 emissions (% of total fuel combustion) of El Salvador in 1997 and the CO2 emissions (% of total fuel combustion) of Namibia in 1998?
Keep it short and to the point. -11.84. What is the difference between the CO2 emissions (% of total fuel combustion) of Lebanon in 1997 and the CO2 emissions (% of total fuel combustion) of Namibia in 1998?
Your answer should be very brief. -27.79. What is the average CO2 emissions (% of total fuel combustion) in Costa Rica per year?
Offer a very short reply. 62.29. What is the average CO2 emissions (% of total fuel combustion) of El Salvador per year?
Offer a terse response. 46.07. What is the average CO2 emissions (% of total fuel combustion) in Lebanon per year?
Your response must be concise. 33.56. What is the average CO2 emissions (% of total fuel combustion) of Namibia per year?
Offer a very short reply. 44.29. In the year 1992, what is the difference between the CO2 emissions (% of total fuel combustion) in Costa Rica and CO2 emissions (% of total fuel combustion) in El Salvador?
Your answer should be very brief. 13.72. In the year 1992, what is the difference between the CO2 emissions (% of total fuel combustion) of Costa Rica and CO2 emissions (% of total fuel combustion) of Lebanon?
Your answer should be very brief. 15.6. In the year 1992, what is the difference between the CO2 emissions (% of total fuel combustion) in Costa Rica and CO2 emissions (% of total fuel combustion) in Namibia?
Your answer should be compact. 21.06. In the year 1992, what is the difference between the CO2 emissions (% of total fuel combustion) of El Salvador and CO2 emissions (% of total fuel combustion) of Lebanon?
Your answer should be compact. 1.87. In the year 1992, what is the difference between the CO2 emissions (% of total fuel combustion) of El Salvador and CO2 emissions (% of total fuel combustion) of Namibia?
Your answer should be very brief. 7.33. In the year 1992, what is the difference between the CO2 emissions (% of total fuel combustion) of Lebanon and CO2 emissions (% of total fuel combustion) of Namibia?
Offer a very short reply. 5.46. In the year 1993, what is the difference between the CO2 emissions (% of total fuel combustion) in Costa Rica and CO2 emissions (% of total fuel combustion) in El Salvador?
Keep it short and to the point. 17.28. In the year 1993, what is the difference between the CO2 emissions (% of total fuel combustion) of Costa Rica and CO2 emissions (% of total fuel combustion) of Lebanon?
Offer a very short reply. 27.77. In the year 1993, what is the difference between the CO2 emissions (% of total fuel combustion) of Costa Rica and CO2 emissions (% of total fuel combustion) of Namibia?
Give a very brief answer. 27.93. In the year 1993, what is the difference between the CO2 emissions (% of total fuel combustion) of El Salvador and CO2 emissions (% of total fuel combustion) of Lebanon?
Offer a terse response. 10.48. In the year 1993, what is the difference between the CO2 emissions (% of total fuel combustion) of El Salvador and CO2 emissions (% of total fuel combustion) of Namibia?
Offer a terse response. 10.65. In the year 1993, what is the difference between the CO2 emissions (% of total fuel combustion) in Lebanon and CO2 emissions (% of total fuel combustion) in Namibia?
Make the answer very short. 0.17. In the year 1994, what is the difference between the CO2 emissions (% of total fuel combustion) of Costa Rica and CO2 emissions (% of total fuel combustion) of El Salvador?
Provide a short and direct response. 13.96. In the year 1994, what is the difference between the CO2 emissions (% of total fuel combustion) in Costa Rica and CO2 emissions (% of total fuel combustion) in Lebanon?
Your answer should be compact. 27.05. In the year 1994, what is the difference between the CO2 emissions (% of total fuel combustion) of Costa Rica and CO2 emissions (% of total fuel combustion) of Namibia?
Your response must be concise. 23.44. In the year 1994, what is the difference between the CO2 emissions (% of total fuel combustion) of El Salvador and CO2 emissions (% of total fuel combustion) of Lebanon?
Offer a terse response. 13.08. In the year 1994, what is the difference between the CO2 emissions (% of total fuel combustion) of El Salvador and CO2 emissions (% of total fuel combustion) of Namibia?
Ensure brevity in your answer.  9.48. In the year 1994, what is the difference between the CO2 emissions (% of total fuel combustion) of Lebanon and CO2 emissions (% of total fuel combustion) of Namibia?
Offer a very short reply. -3.61. In the year 1995, what is the difference between the CO2 emissions (% of total fuel combustion) of Costa Rica and CO2 emissions (% of total fuel combustion) of El Salvador?
Offer a very short reply. 12.83. In the year 1995, what is the difference between the CO2 emissions (% of total fuel combustion) of Costa Rica and CO2 emissions (% of total fuel combustion) of Lebanon?
Ensure brevity in your answer.  25.96. In the year 1995, what is the difference between the CO2 emissions (% of total fuel combustion) in Costa Rica and CO2 emissions (% of total fuel combustion) in Namibia?
Your answer should be very brief. 23.72. In the year 1995, what is the difference between the CO2 emissions (% of total fuel combustion) of El Salvador and CO2 emissions (% of total fuel combustion) of Lebanon?
Keep it short and to the point. 13.14. In the year 1995, what is the difference between the CO2 emissions (% of total fuel combustion) of El Salvador and CO2 emissions (% of total fuel combustion) of Namibia?
Your answer should be very brief. 10.89. In the year 1995, what is the difference between the CO2 emissions (% of total fuel combustion) of Lebanon and CO2 emissions (% of total fuel combustion) of Namibia?
Provide a succinct answer. -2.25. In the year 1996, what is the difference between the CO2 emissions (% of total fuel combustion) in Costa Rica and CO2 emissions (% of total fuel combustion) in El Salvador?
Your response must be concise. 11.49. In the year 1996, what is the difference between the CO2 emissions (% of total fuel combustion) in Costa Rica and CO2 emissions (% of total fuel combustion) in Lebanon?
Offer a very short reply. 30.64. In the year 1996, what is the difference between the CO2 emissions (% of total fuel combustion) in Costa Rica and CO2 emissions (% of total fuel combustion) in Namibia?
Offer a terse response. 8.3. In the year 1996, what is the difference between the CO2 emissions (% of total fuel combustion) of El Salvador and CO2 emissions (% of total fuel combustion) of Lebanon?
Keep it short and to the point. 19.16. In the year 1996, what is the difference between the CO2 emissions (% of total fuel combustion) of El Salvador and CO2 emissions (% of total fuel combustion) of Namibia?
Your answer should be very brief. -3.19. In the year 1996, what is the difference between the CO2 emissions (% of total fuel combustion) of Lebanon and CO2 emissions (% of total fuel combustion) of Namibia?
Provide a succinct answer. -22.34. In the year 1997, what is the difference between the CO2 emissions (% of total fuel combustion) in Costa Rica and CO2 emissions (% of total fuel combustion) in El Salvador?
Provide a short and direct response. 22.55. In the year 1997, what is the difference between the CO2 emissions (% of total fuel combustion) in Costa Rica and CO2 emissions (% of total fuel combustion) in Lebanon?
Offer a terse response. 38.49. In the year 1997, what is the difference between the CO2 emissions (% of total fuel combustion) in Costa Rica and CO2 emissions (% of total fuel combustion) in Namibia?
Your response must be concise. 11.35. In the year 1997, what is the difference between the CO2 emissions (% of total fuel combustion) of El Salvador and CO2 emissions (% of total fuel combustion) of Lebanon?
Offer a very short reply. 15.95. In the year 1997, what is the difference between the CO2 emissions (% of total fuel combustion) in El Salvador and CO2 emissions (% of total fuel combustion) in Namibia?
Offer a very short reply. -11.2. In the year 1997, what is the difference between the CO2 emissions (% of total fuel combustion) in Lebanon and CO2 emissions (% of total fuel combustion) in Namibia?
Ensure brevity in your answer.  -27.14. In the year 1998, what is the difference between the CO2 emissions (% of total fuel combustion) in Costa Rica and CO2 emissions (% of total fuel combustion) in El Salvador?
Provide a succinct answer. 21.73. In the year 1998, what is the difference between the CO2 emissions (% of total fuel combustion) of Costa Rica and CO2 emissions (% of total fuel combustion) of Lebanon?
Make the answer very short. 35.63. In the year 1998, what is the difference between the CO2 emissions (% of total fuel combustion) of Costa Rica and CO2 emissions (% of total fuel combustion) of Namibia?
Offer a terse response. 10.24. In the year 1998, what is the difference between the CO2 emissions (% of total fuel combustion) of El Salvador and CO2 emissions (% of total fuel combustion) of Lebanon?
Give a very brief answer. 13.9. In the year 1998, what is the difference between the CO2 emissions (% of total fuel combustion) in El Salvador and CO2 emissions (% of total fuel combustion) in Namibia?
Provide a succinct answer. -11.49. In the year 1998, what is the difference between the CO2 emissions (% of total fuel combustion) in Lebanon and CO2 emissions (% of total fuel combustion) in Namibia?
Your response must be concise. -25.39. What is the ratio of the CO2 emissions (% of total fuel combustion) of Costa Rica in 1992 to that in 1993?
Ensure brevity in your answer.  0.96. What is the ratio of the CO2 emissions (% of total fuel combustion) in El Salvador in 1992 to that in 1993?
Make the answer very short. 1.02. What is the ratio of the CO2 emissions (% of total fuel combustion) of Lebanon in 1992 to that in 1993?
Provide a short and direct response. 1.26. What is the ratio of the CO2 emissions (% of total fuel combustion) in Namibia in 1992 to that in 1993?
Provide a short and direct response. 1.12. What is the ratio of the CO2 emissions (% of total fuel combustion) of Costa Rica in 1992 to that in 1994?
Keep it short and to the point. 1.06. What is the ratio of the CO2 emissions (% of total fuel combustion) in El Salvador in 1992 to that in 1994?
Ensure brevity in your answer.  1.09. What is the ratio of the CO2 emissions (% of total fuel combustion) in Lebanon in 1992 to that in 1994?
Your answer should be very brief. 1.48. What is the ratio of the CO2 emissions (% of total fuel combustion) in Namibia in 1992 to that in 1994?
Keep it short and to the point. 1.17. What is the ratio of the CO2 emissions (% of total fuel combustion) in Costa Rica in 1992 to that in 1995?
Your answer should be compact. 1.07. What is the ratio of the CO2 emissions (% of total fuel combustion) of El Salvador in 1992 to that in 1995?
Make the answer very short. 1.07. What is the ratio of the CO2 emissions (% of total fuel combustion) of Lebanon in 1992 to that in 1995?
Ensure brevity in your answer.  1.44. What is the ratio of the CO2 emissions (% of total fuel combustion) in Namibia in 1992 to that in 1995?
Offer a very short reply. 1.19. What is the ratio of the CO2 emissions (% of total fuel combustion) in Costa Rica in 1992 to that in 1996?
Your response must be concise. 0.99. What is the ratio of the CO2 emissions (% of total fuel combustion) in El Salvador in 1992 to that in 1996?
Your answer should be very brief. 0.95. What is the ratio of the CO2 emissions (% of total fuel combustion) of Lebanon in 1992 to that in 1996?
Offer a terse response. 1.46. What is the ratio of the CO2 emissions (% of total fuel combustion) of Namibia in 1992 to that in 1996?
Offer a terse response. 0.76. What is the ratio of the CO2 emissions (% of total fuel combustion) in Costa Rica in 1992 to that in 1997?
Keep it short and to the point. 0.95. What is the ratio of the CO2 emissions (% of total fuel combustion) in El Salvador in 1992 to that in 1997?
Your answer should be compact. 1.13. What is the ratio of the CO2 emissions (% of total fuel combustion) of Lebanon in 1992 to that in 1997?
Offer a very short reply. 1.72. What is the ratio of the CO2 emissions (% of total fuel combustion) of Namibia in 1992 to that in 1997?
Your response must be concise. 0.76. What is the ratio of the CO2 emissions (% of total fuel combustion) in Costa Rica in 1992 to that in 1998?
Your answer should be compact. 0.95. What is the ratio of the CO2 emissions (% of total fuel combustion) in El Salvador in 1992 to that in 1998?
Offer a very short reply. 1.12. What is the ratio of the CO2 emissions (% of total fuel combustion) of Lebanon in 1992 to that in 1998?
Provide a succinct answer. 1.58. What is the ratio of the CO2 emissions (% of total fuel combustion) of Namibia in 1992 to that in 1998?
Keep it short and to the point. 0.75. What is the ratio of the CO2 emissions (% of total fuel combustion) of Costa Rica in 1993 to that in 1994?
Offer a terse response. 1.11. What is the ratio of the CO2 emissions (% of total fuel combustion) of El Salvador in 1993 to that in 1994?
Make the answer very short. 1.06. What is the ratio of the CO2 emissions (% of total fuel combustion) in Lebanon in 1993 to that in 1994?
Offer a very short reply. 1.17. What is the ratio of the CO2 emissions (% of total fuel combustion) in Namibia in 1993 to that in 1994?
Ensure brevity in your answer.  1.05. What is the ratio of the CO2 emissions (% of total fuel combustion) in Costa Rica in 1993 to that in 1995?
Your response must be concise. 1.11. What is the ratio of the CO2 emissions (% of total fuel combustion) of El Salvador in 1993 to that in 1995?
Offer a terse response. 1.04. What is the ratio of the CO2 emissions (% of total fuel combustion) of Lebanon in 1993 to that in 1995?
Offer a very short reply. 1.14. What is the ratio of the CO2 emissions (% of total fuel combustion) in Namibia in 1993 to that in 1995?
Give a very brief answer. 1.06. What is the ratio of the CO2 emissions (% of total fuel combustion) of Costa Rica in 1993 to that in 1996?
Provide a succinct answer. 1.03. What is the ratio of the CO2 emissions (% of total fuel combustion) in El Salvador in 1993 to that in 1996?
Make the answer very short. 0.93. What is the ratio of the CO2 emissions (% of total fuel combustion) in Lebanon in 1993 to that in 1996?
Make the answer very short. 1.16. What is the ratio of the CO2 emissions (% of total fuel combustion) of Namibia in 1993 to that in 1996?
Keep it short and to the point. 0.68. What is the ratio of the CO2 emissions (% of total fuel combustion) in Costa Rica in 1993 to that in 1997?
Give a very brief answer. 0.99. What is the ratio of the CO2 emissions (% of total fuel combustion) in El Salvador in 1993 to that in 1997?
Make the answer very short. 1.1. What is the ratio of the CO2 emissions (% of total fuel combustion) in Lebanon in 1993 to that in 1997?
Offer a very short reply. 1.37. What is the ratio of the CO2 emissions (% of total fuel combustion) in Namibia in 1993 to that in 1997?
Keep it short and to the point. 0.68. What is the ratio of the CO2 emissions (% of total fuel combustion) of Costa Rica in 1993 to that in 1998?
Give a very brief answer. 0.99. What is the ratio of the CO2 emissions (% of total fuel combustion) of El Salvador in 1993 to that in 1998?
Provide a short and direct response. 1.09. What is the ratio of the CO2 emissions (% of total fuel combustion) of Lebanon in 1993 to that in 1998?
Ensure brevity in your answer.  1.25. What is the ratio of the CO2 emissions (% of total fuel combustion) of Namibia in 1993 to that in 1998?
Keep it short and to the point. 0.67. What is the ratio of the CO2 emissions (% of total fuel combustion) of El Salvador in 1994 to that in 1995?
Make the answer very short. 0.98. What is the ratio of the CO2 emissions (% of total fuel combustion) in Lebanon in 1994 to that in 1995?
Offer a very short reply. 0.97. What is the ratio of the CO2 emissions (% of total fuel combustion) of Namibia in 1994 to that in 1995?
Your answer should be very brief. 1.01. What is the ratio of the CO2 emissions (% of total fuel combustion) in Costa Rica in 1994 to that in 1996?
Provide a short and direct response. 0.94. What is the ratio of the CO2 emissions (% of total fuel combustion) of El Salvador in 1994 to that in 1996?
Your answer should be compact. 0.87. What is the ratio of the CO2 emissions (% of total fuel combustion) in Lebanon in 1994 to that in 1996?
Ensure brevity in your answer.  0.99. What is the ratio of the CO2 emissions (% of total fuel combustion) in Namibia in 1994 to that in 1996?
Your answer should be compact. 0.65. What is the ratio of the CO2 emissions (% of total fuel combustion) in Costa Rica in 1994 to that in 1997?
Offer a terse response. 0.89. What is the ratio of the CO2 emissions (% of total fuel combustion) of El Salvador in 1994 to that in 1997?
Provide a succinct answer. 1.04. What is the ratio of the CO2 emissions (% of total fuel combustion) in Lebanon in 1994 to that in 1997?
Your answer should be compact. 1.16. What is the ratio of the CO2 emissions (% of total fuel combustion) in Namibia in 1994 to that in 1997?
Keep it short and to the point. 0.65. What is the ratio of the CO2 emissions (% of total fuel combustion) of Costa Rica in 1994 to that in 1998?
Your answer should be very brief. 0.9. What is the ratio of the CO2 emissions (% of total fuel combustion) of El Salvador in 1994 to that in 1998?
Ensure brevity in your answer.  1.03. What is the ratio of the CO2 emissions (% of total fuel combustion) in Lebanon in 1994 to that in 1998?
Offer a terse response. 1.07. What is the ratio of the CO2 emissions (% of total fuel combustion) in Namibia in 1994 to that in 1998?
Provide a short and direct response. 0.64. What is the ratio of the CO2 emissions (% of total fuel combustion) in Costa Rica in 1995 to that in 1996?
Give a very brief answer. 0.93. What is the ratio of the CO2 emissions (% of total fuel combustion) of El Salvador in 1995 to that in 1996?
Your answer should be very brief. 0.89. What is the ratio of the CO2 emissions (% of total fuel combustion) in Lebanon in 1995 to that in 1996?
Keep it short and to the point. 1.01. What is the ratio of the CO2 emissions (% of total fuel combustion) in Namibia in 1995 to that in 1996?
Ensure brevity in your answer.  0.64. What is the ratio of the CO2 emissions (% of total fuel combustion) in Costa Rica in 1995 to that in 1997?
Provide a short and direct response. 0.89. What is the ratio of the CO2 emissions (% of total fuel combustion) of El Salvador in 1995 to that in 1997?
Offer a terse response. 1.06. What is the ratio of the CO2 emissions (% of total fuel combustion) of Lebanon in 1995 to that in 1997?
Provide a succinct answer. 1.2. What is the ratio of the CO2 emissions (% of total fuel combustion) of Namibia in 1995 to that in 1997?
Offer a very short reply. 0.64. What is the ratio of the CO2 emissions (% of total fuel combustion) in Costa Rica in 1995 to that in 1998?
Keep it short and to the point. 0.9. What is the ratio of the CO2 emissions (% of total fuel combustion) of El Salvador in 1995 to that in 1998?
Give a very brief answer. 1.05. What is the ratio of the CO2 emissions (% of total fuel combustion) of Lebanon in 1995 to that in 1998?
Give a very brief answer. 1.1. What is the ratio of the CO2 emissions (% of total fuel combustion) of Namibia in 1995 to that in 1998?
Your answer should be very brief. 0.63. What is the ratio of the CO2 emissions (% of total fuel combustion) in Costa Rica in 1996 to that in 1997?
Offer a terse response. 0.95. What is the ratio of the CO2 emissions (% of total fuel combustion) in El Salvador in 1996 to that in 1997?
Your response must be concise. 1.19. What is the ratio of the CO2 emissions (% of total fuel combustion) in Lebanon in 1996 to that in 1997?
Provide a succinct answer. 1.18. What is the ratio of the CO2 emissions (% of total fuel combustion) of Costa Rica in 1996 to that in 1998?
Give a very brief answer. 0.96. What is the ratio of the CO2 emissions (% of total fuel combustion) in El Salvador in 1996 to that in 1998?
Keep it short and to the point. 1.18. What is the ratio of the CO2 emissions (% of total fuel combustion) in Lebanon in 1996 to that in 1998?
Offer a terse response. 1.08. What is the ratio of the CO2 emissions (% of total fuel combustion) in Namibia in 1996 to that in 1998?
Ensure brevity in your answer.  0.99. What is the ratio of the CO2 emissions (% of total fuel combustion) in Lebanon in 1997 to that in 1998?
Ensure brevity in your answer.  0.92. What is the difference between the highest and the second highest CO2 emissions (% of total fuel combustion) in Costa Rica?
Your answer should be compact. 0.47. What is the difference between the highest and the second highest CO2 emissions (% of total fuel combustion) in El Salvador?
Give a very brief answer. 2.66. What is the difference between the highest and the second highest CO2 emissions (% of total fuel combustion) in Lebanon?
Keep it short and to the point. 9.66. What is the difference between the highest and the second highest CO2 emissions (% of total fuel combustion) in Namibia?
Provide a short and direct response. 0.56. What is the difference between the highest and the lowest CO2 emissions (% of total fuel combustion) in Costa Rica?
Keep it short and to the point. 7.25. What is the difference between the highest and the lowest CO2 emissions (% of total fuel combustion) in El Salvador?
Make the answer very short. 8.09. What is the difference between the highest and the lowest CO2 emissions (% of total fuel combustion) in Lebanon?
Ensure brevity in your answer.  19.5. What is the difference between the highest and the lowest CO2 emissions (% of total fuel combustion) of Namibia?
Your answer should be very brief. 20.26. 